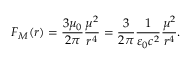Convert formula to latex. <formula><loc_0><loc_0><loc_500><loc_500>F _ { M } ( r ) = \frac { 3 \mu _ { 0 } } { 2 \pi } \frac { \mu ^ { 2 } } { r ^ { 4 } } = \frac { 3 } { 2 \pi } \frac { 1 } { \varepsilon _ { 0 } c ^ { 2 } } \frac { \mu ^ { 2 } } { r ^ { 4 } } .</formula> 